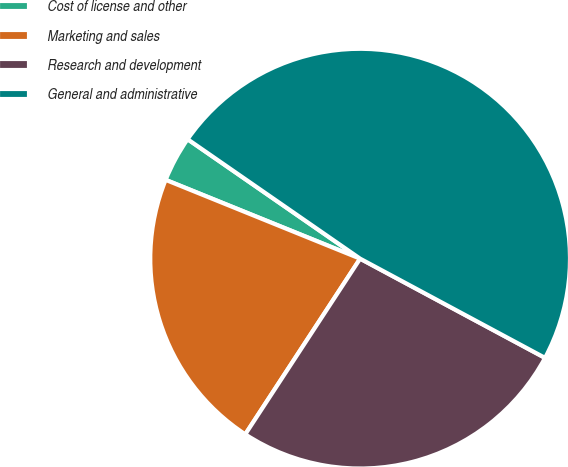Convert chart to OTSL. <chart><loc_0><loc_0><loc_500><loc_500><pie_chart><fcel>Cost of license and other<fcel>Marketing and sales<fcel>Research and development<fcel>General and administrative<nl><fcel>3.51%<fcel>21.91%<fcel>26.38%<fcel>48.2%<nl></chart> 